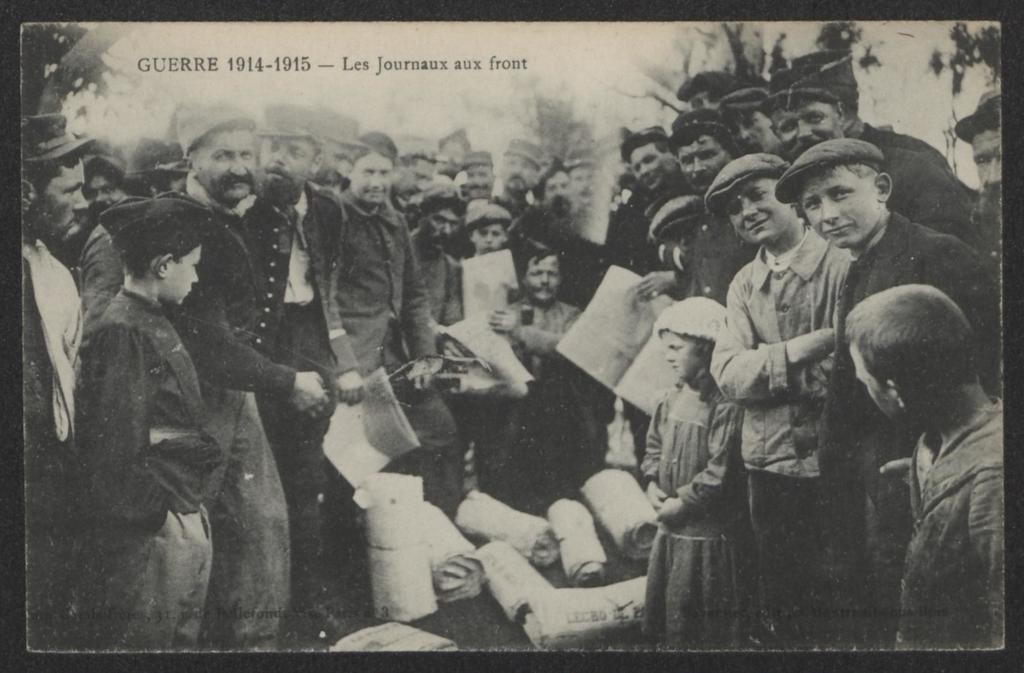Describe this image in one or two sentences. It is the black and white image in which there are so many people in the middle. They are holding the papers. At the bottom there are rolls of papers on the ground. In the background there are trees. At the top there is text. 